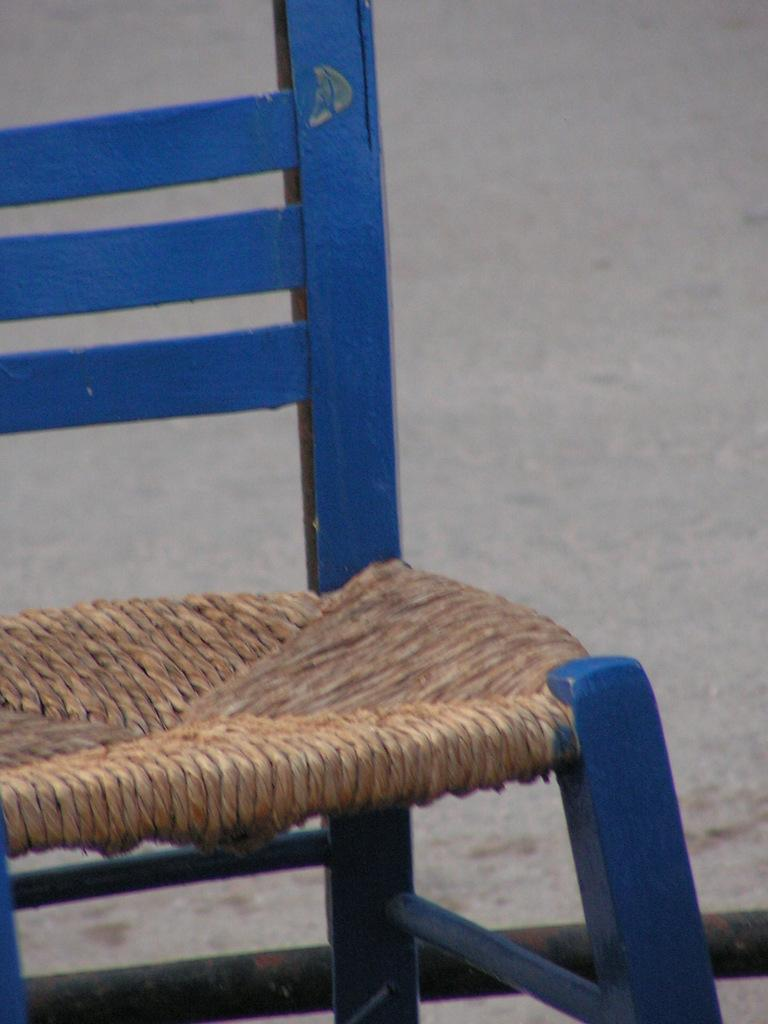What type of furniture is in the image? There is a chair in the image. How is the chair depicted in the image? The chair is truncated. What color is the background of the image? The background of the image is grey. What type of stitch is used to create the chair's design in the image? There is no information about the type of stitch used to create the chair's design in the image. 